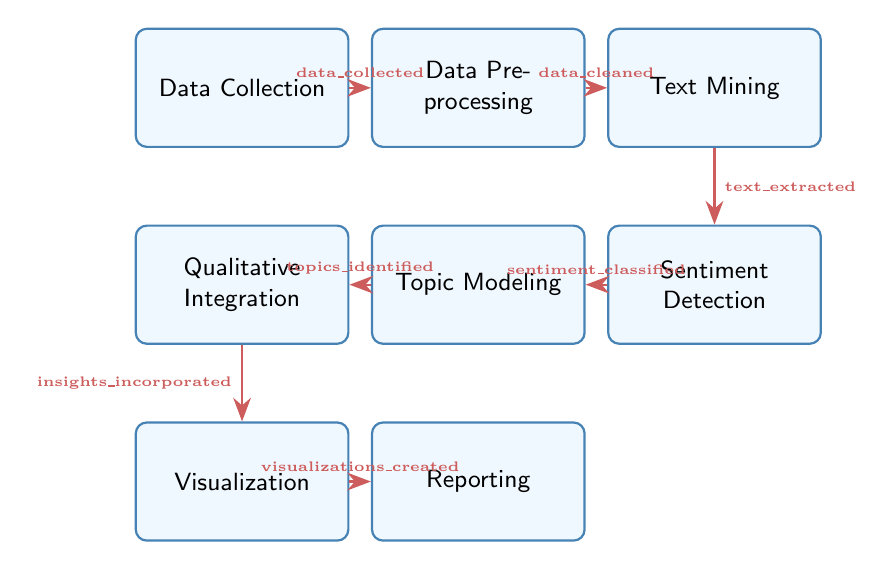What is the first state in the process? The first state indicated in the diagram is "Data Collection." This is identified as there are no other nodes to the left of it, marking it as the starting point.
Answer: Data Collection How many states are in the diagram? By counting the unique named states in the diagram, there are eight distinct states: Data Collection, Data Preprocessing, Text Mining, Sentiment Detection, Topic Modeling, Qualitative Integration, Visualization, and Reporting.
Answer: Eight What is the trigger for transitioning from Data Preprocessing to Text Mining? The transition from Data Preprocessing to Text Mining is defined by the trigger "data_cleaned," which is specifically shown on the arrow between these two nodes.
Answer: data_cleaned Which state follows Topic Modeling? The state that follows Topic Modeling, as per the transitions shown in the diagram, is Qualitative Integration. This is directly connected by the arrow from Topic Modeling to Qualitative Integration.
Answer: Qualitative Integration What is the relationship between the states Sentiment Detection and Topic Modeling? The relationship is one of sequential progression, where Sentiment Detection must occur prior to Topic Modeling as signified by the directed arrow labeled "sentiment_classified" that connects them.
Answer: Sequential progression What state does Visualization lead to? According to the transitions, Visualization leads to Reporting. This is clearly indicated by the arrow that points directly from Visualization to Reporting.
Answer: Reporting What is the trigger for going from Qualitative Integration to Visualization? The trigger that enables the transition from Qualitative Integration to Visualization is "insights_incorporated," which is labeled on the connecting arrow.
Answer: insights_incorporated How many transitions are represented in the diagram? There are seven transitions connecting the eight states, which can be counted based on the directed arrows leading from one state to another within the diagram.
Answer: Seven What is the last stage in the Social Media Sentiment Analysis Process? The last stage in the diagram is Reporting, which is the final state that all workflows lead to after passing through all other states.
Answer: Reporting 